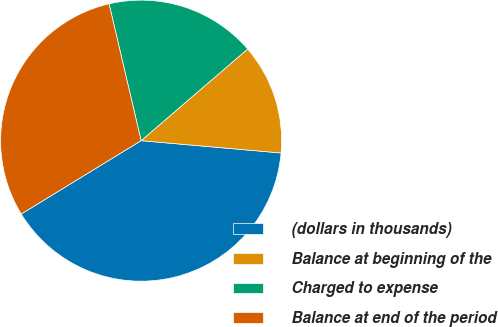<chart> <loc_0><loc_0><loc_500><loc_500><pie_chart><fcel>(dollars in thousands)<fcel>Balance at beginning of the<fcel>Charged to expense<fcel>Balance at end of the period<nl><fcel>39.86%<fcel>12.7%<fcel>17.36%<fcel>30.07%<nl></chart> 